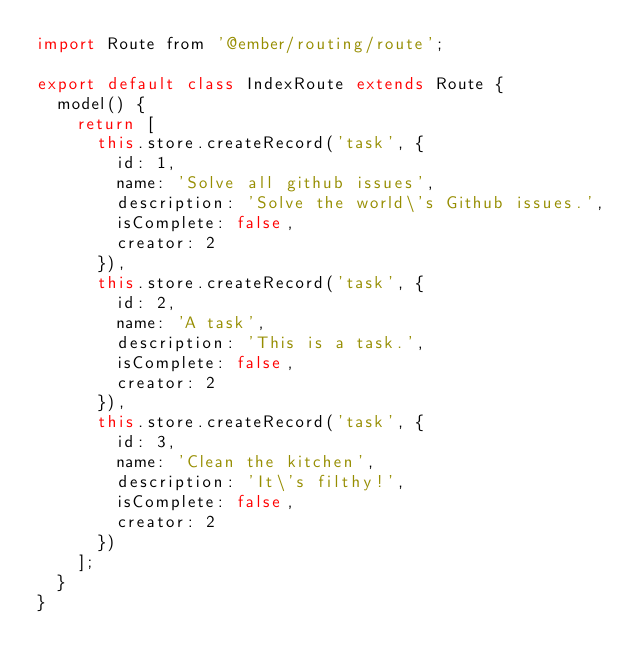Convert code to text. <code><loc_0><loc_0><loc_500><loc_500><_JavaScript_>import Route from '@ember/routing/route';

export default class IndexRoute extends Route {
  model() {
    return [
      this.store.createRecord('task', {
        id: 1,
        name: 'Solve all github issues',
        description: 'Solve the world\'s Github issues.',
        isComplete: false,
        creator: 2
      }),
      this.store.createRecord('task', {
        id: 2,
        name: 'A task',
        description: 'This is a task.',
        isComplete: false,
        creator: 2
      }),
      this.store.createRecord('task', {
        id: 3,
        name: 'Clean the kitchen',
        description: 'It\'s filthy!',
        isComplete: false,
        creator: 2
      })
    ];
  }
}
</code> 